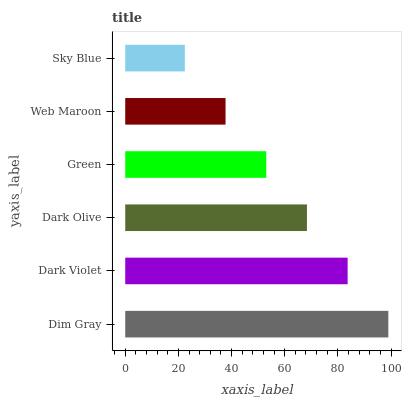Is Sky Blue the minimum?
Answer yes or no. Yes. Is Dim Gray the maximum?
Answer yes or no. Yes. Is Dark Violet the minimum?
Answer yes or no. No. Is Dark Violet the maximum?
Answer yes or no. No. Is Dim Gray greater than Dark Violet?
Answer yes or no. Yes. Is Dark Violet less than Dim Gray?
Answer yes or no. Yes. Is Dark Violet greater than Dim Gray?
Answer yes or no. No. Is Dim Gray less than Dark Violet?
Answer yes or no. No. Is Dark Olive the high median?
Answer yes or no. Yes. Is Green the low median?
Answer yes or no. Yes. Is Sky Blue the high median?
Answer yes or no. No. Is Web Maroon the low median?
Answer yes or no. No. 